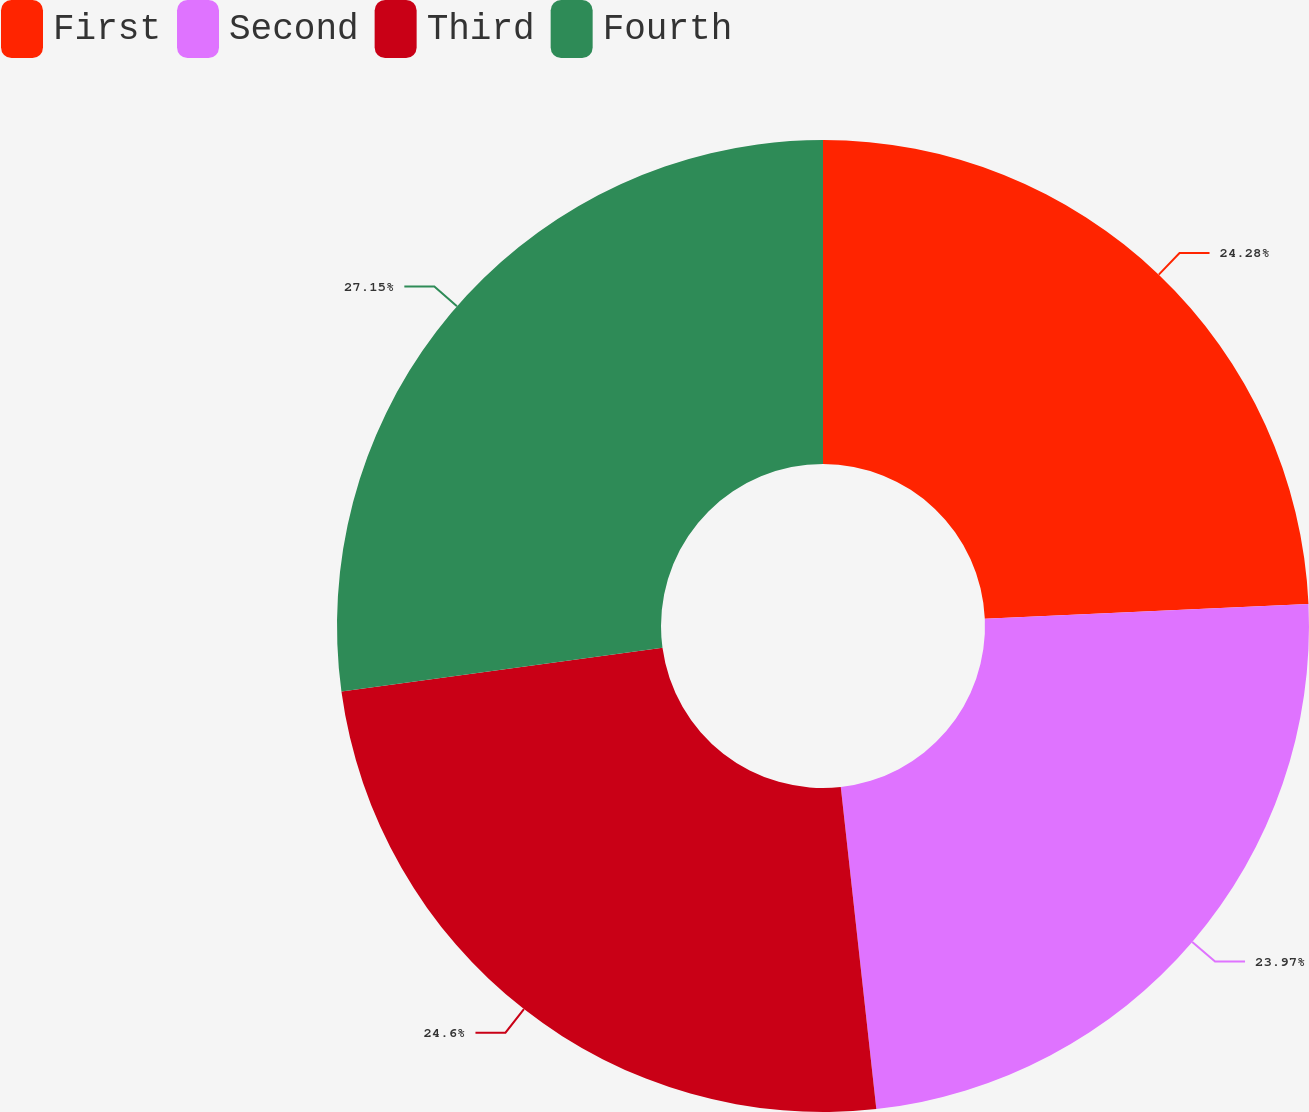Convert chart to OTSL. <chart><loc_0><loc_0><loc_500><loc_500><pie_chart><fcel>First<fcel>Second<fcel>Third<fcel>Fourth<nl><fcel>24.28%<fcel>23.97%<fcel>24.6%<fcel>27.15%<nl></chart> 